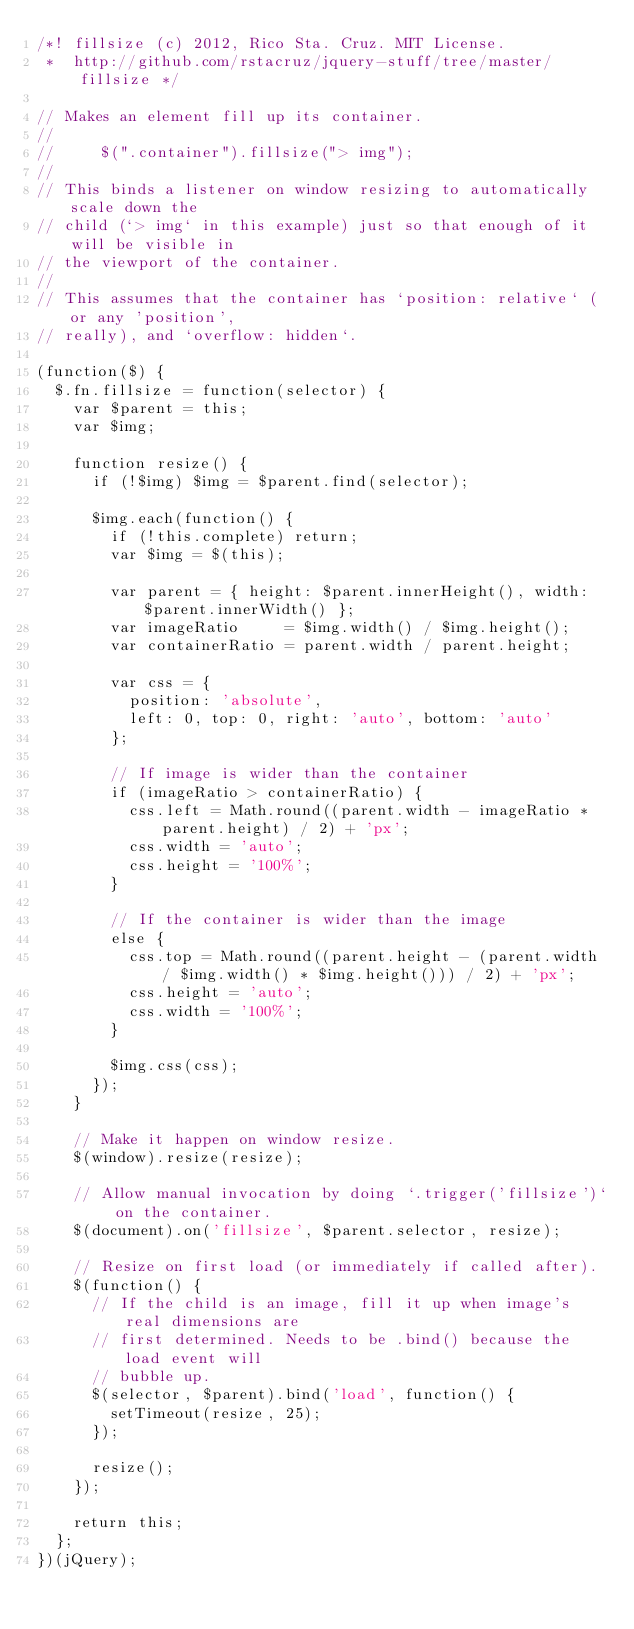Convert code to text. <code><loc_0><loc_0><loc_500><loc_500><_JavaScript_>/*! fillsize (c) 2012, Rico Sta. Cruz. MIT License.
 *  http://github.com/rstacruz/jquery-stuff/tree/master/fillsize */

// Makes an element fill up its container.
//
//     $(".container").fillsize("> img");
//
// This binds a listener on window resizing to automatically scale down the
// child (`> img` in this example) just so that enough of it will be visible in
// the viewport of the container.
// 
// This assumes that the container has `position: relative` (or any 'position',
// really), and `overflow: hidden`.

(function($) {
  $.fn.fillsize = function(selector) {
    var $parent = this;
    var $img;

    function resize() {
      if (!$img) $img = $parent.find(selector);

      $img.each(function() {
        if (!this.complete) return;
        var $img = $(this);

        var parent = { height: $parent.innerHeight(), width: $parent.innerWidth() };
        var imageRatio     = $img.width() / $img.height();
        var containerRatio = parent.width / parent.height;

        var css = {
          position: 'absolute',
          left: 0, top: 0, right: 'auto', bottom: 'auto'
        };

        // If image is wider than the container
        if (imageRatio > containerRatio) {
          css.left = Math.round((parent.width - imageRatio * parent.height) / 2) + 'px';
          css.width = 'auto';
          css.height = '100%';
        }

        // If the container is wider than the image
        else {
          css.top = Math.round((parent.height - (parent.width / $img.width() * $img.height())) / 2) + 'px';
          css.height = 'auto';
          css.width = '100%';
        }

        $img.css(css);
      });
    }

    // Make it happen on window resize.
    $(window).resize(resize);

    // Allow manual invocation by doing `.trigger('fillsize')` on the container.
    $(document).on('fillsize', $parent.selector, resize);

    // Resize on first load (or immediately if called after).
    $(function() {
      // If the child is an image, fill it up when image's real dimensions are
      // first determined. Needs to be .bind() because the load event will
      // bubble up.
      $(selector, $parent).bind('load', function() {
        setTimeout(resize, 25);
      });

      resize();
    });

    return this;
  };
})(jQuery);
</code> 